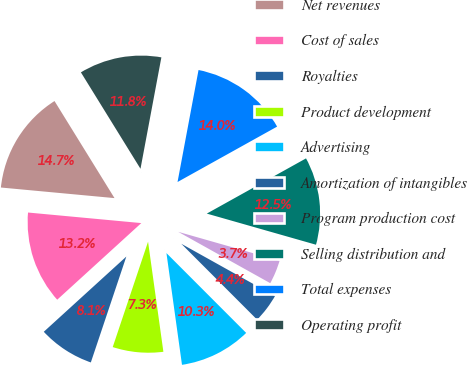Convert chart to OTSL. <chart><loc_0><loc_0><loc_500><loc_500><pie_chart><fcel>Net revenues<fcel>Cost of sales<fcel>Royalties<fcel>Product development<fcel>Advertising<fcel>Amortization of intangibles<fcel>Program production cost<fcel>Selling distribution and<fcel>Total expenses<fcel>Operating profit<nl><fcel>14.71%<fcel>13.24%<fcel>8.09%<fcel>7.35%<fcel>10.29%<fcel>4.41%<fcel>3.68%<fcel>12.5%<fcel>13.97%<fcel>11.76%<nl></chart> 